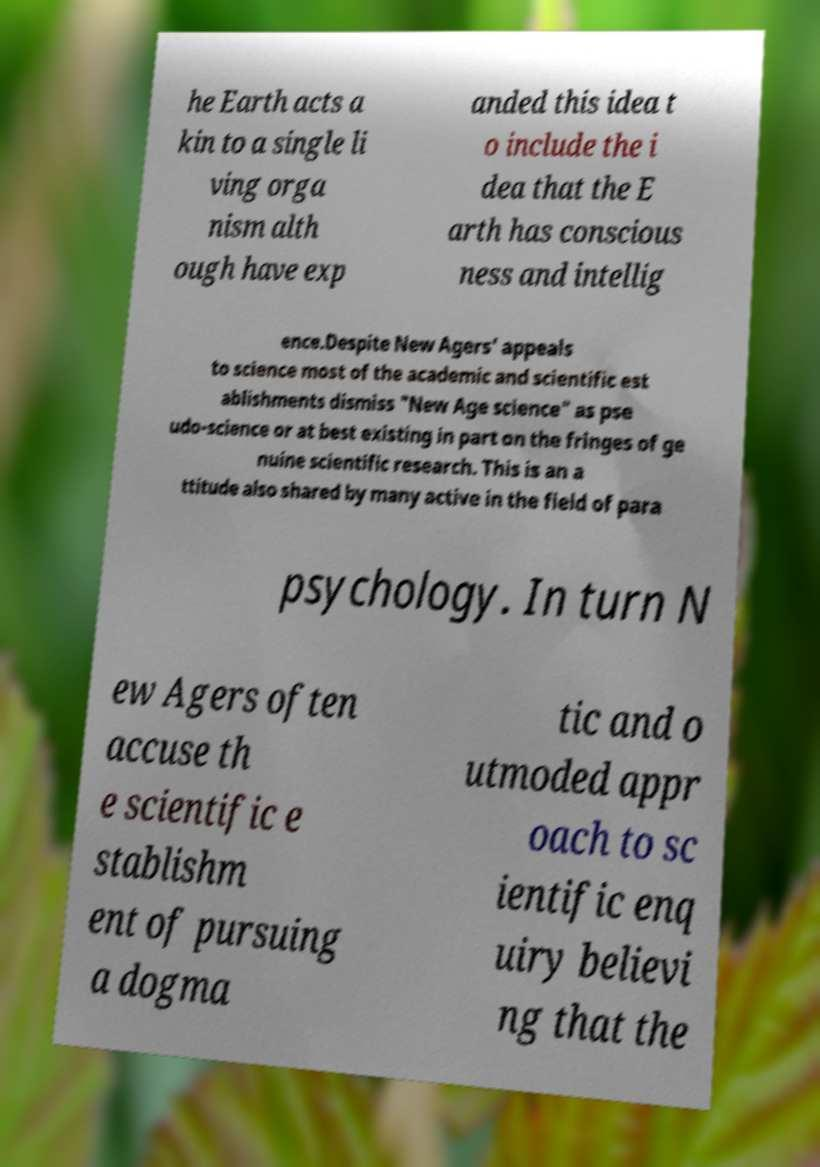I need the written content from this picture converted into text. Can you do that? he Earth acts a kin to a single li ving orga nism alth ough have exp anded this idea t o include the i dea that the E arth has conscious ness and intellig ence.Despite New Agers' appeals to science most of the academic and scientific est ablishments dismiss "New Age science" as pse udo-science or at best existing in part on the fringes of ge nuine scientific research. This is an a ttitude also shared by many active in the field of para psychology. In turn N ew Agers often accuse th e scientific e stablishm ent of pursuing a dogma tic and o utmoded appr oach to sc ientific enq uiry believi ng that the 